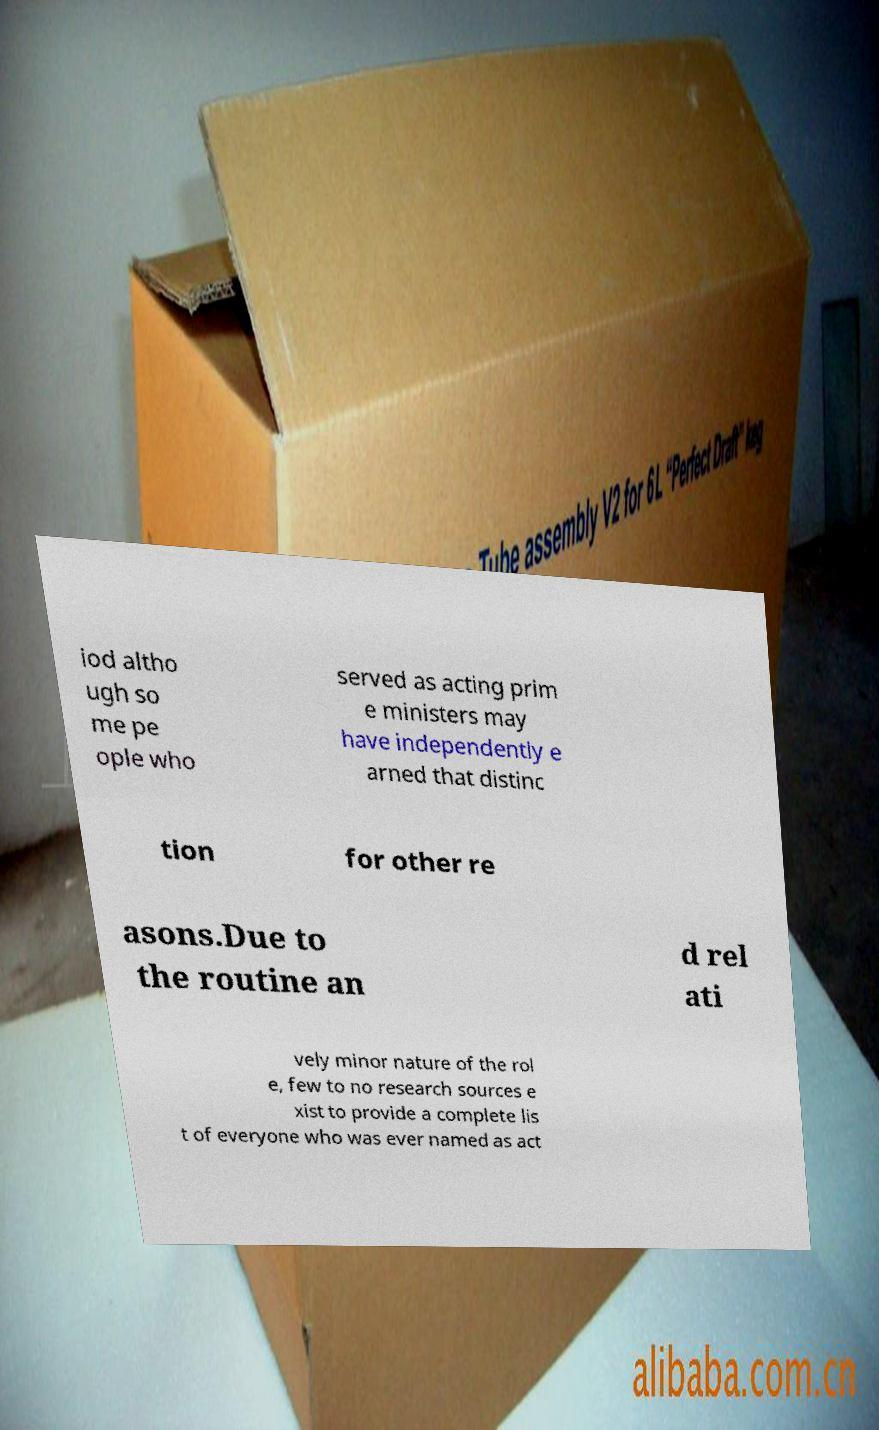Could you assist in decoding the text presented in this image and type it out clearly? iod altho ugh so me pe ople who served as acting prim e ministers may have independently e arned that distinc tion for other re asons.Due to the routine an d rel ati vely minor nature of the rol e, few to no research sources e xist to provide a complete lis t of everyone who was ever named as act 